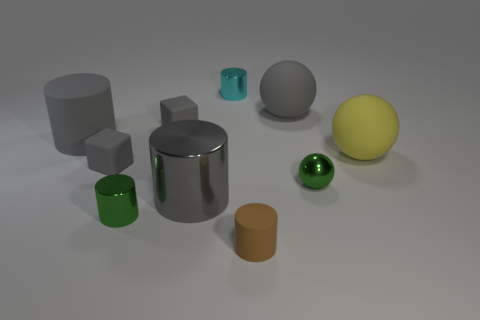Subtract all cyan cylinders. How many cylinders are left? 4 Subtract all green cylinders. How many cylinders are left? 4 Subtract all blocks. How many objects are left? 8 Subtract all blue spheres. Subtract all blue blocks. How many spheres are left? 3 Subtract all gray balls. How many cyan cylinders are left? 1 Subtract all large spheres. Subtract all tiny matte things. How many objects are left? 5 Add 5 small green cylinders. How many small green cylinders are left? 6 Add 6 tiny gray cubes. How many tiny gray cubes exist? 8 Subtract 0 red balls. How many objects are left? 10 Subtract 2 balls. How many balls are left? 1 